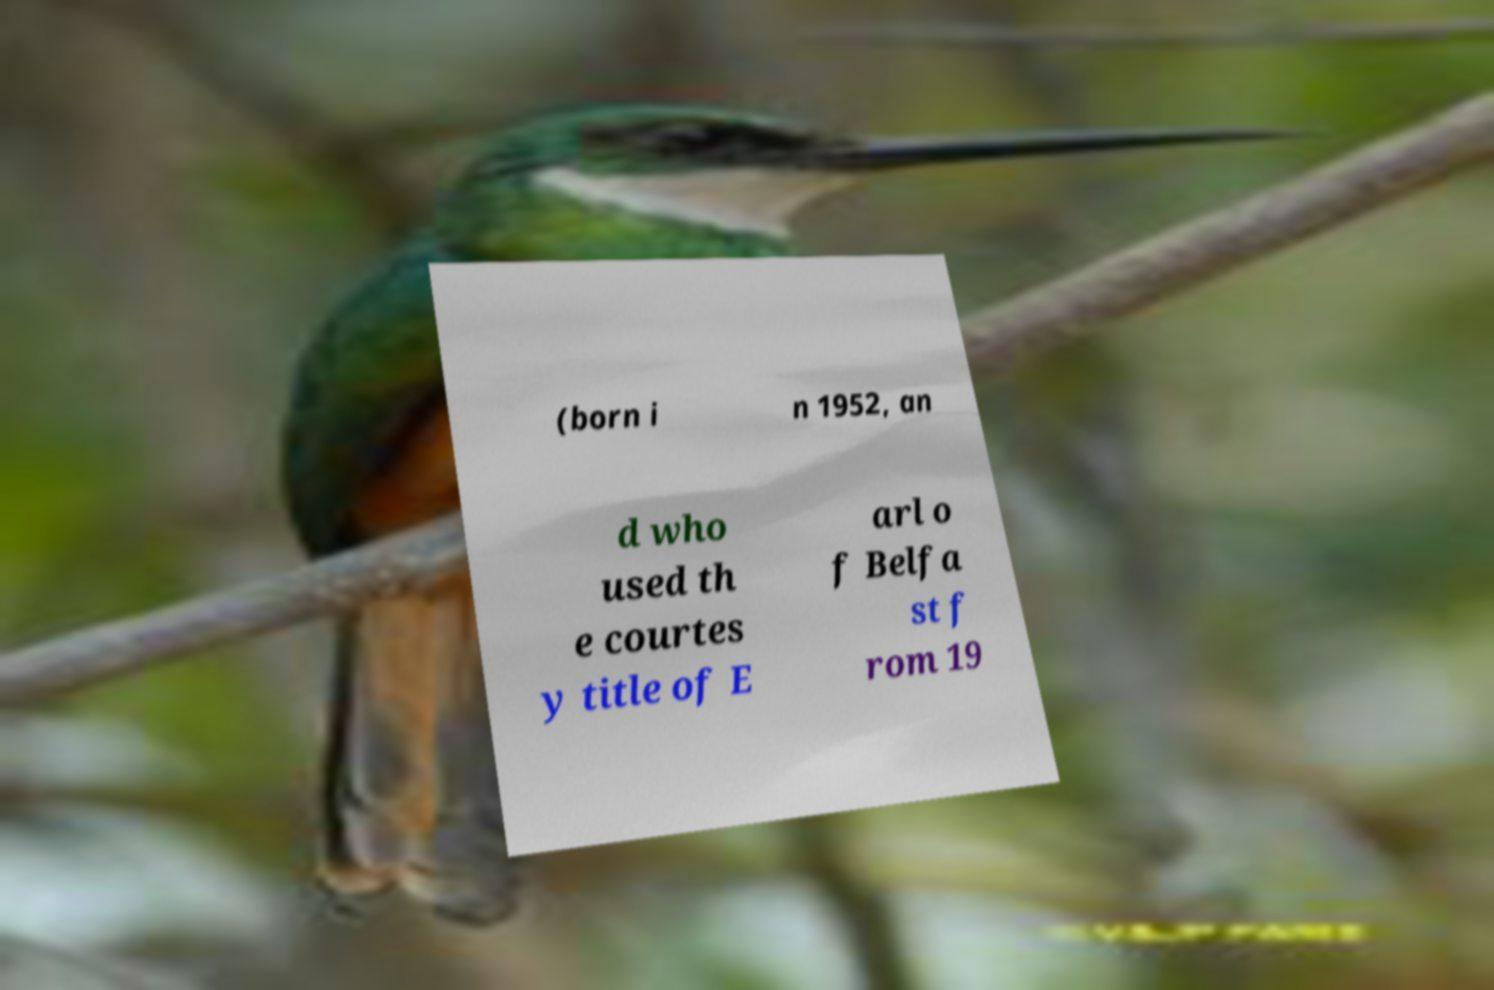Please identify and transcribe the text found in this image. (born i n 1952, an d who used th e courtes y title of E arl o f Belfa st f rom 19 